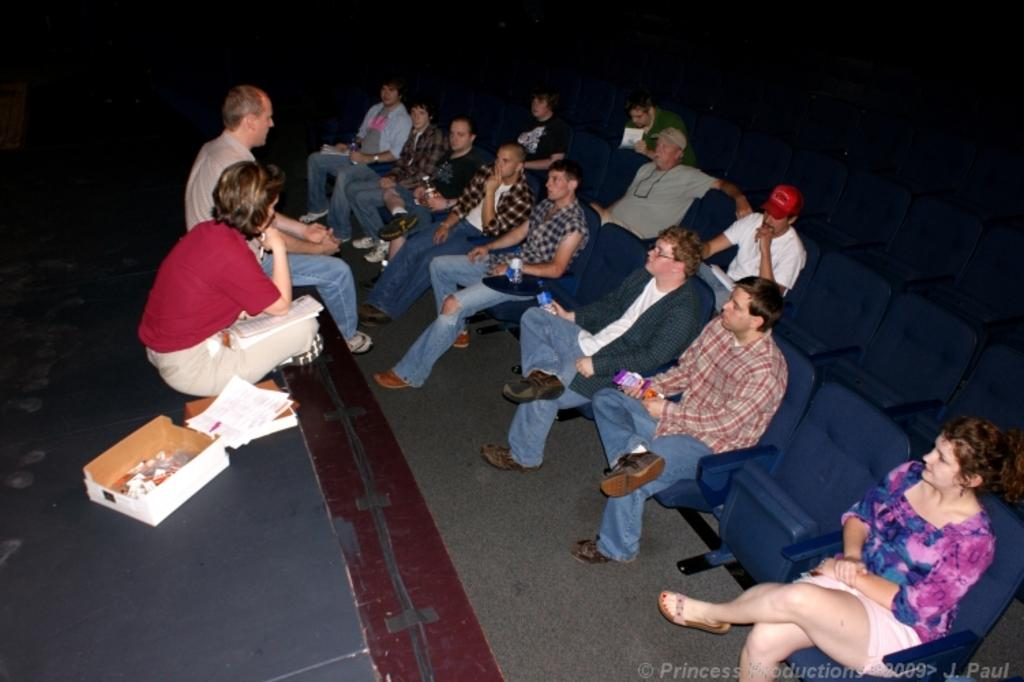How many people are on the stage in the image? There are two people on the stage in the image. What else is on the stage besides the people? There is a box and papers on the stage. What can be seen in front of the stage? There are chairs in front of the stage. What are the people sitting on the chairs doing? There are people sitting on the chairs, but their actions are not visible in the image. What type of agreement was reached by the nation in the image? There is no mention of an agreement or a nation in the image; it only shows two people, a box, papers, chairs, and people sitting on the chairs. 